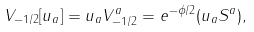<formula> <loc_0><loc_0><loc_500><loc_500>V _ { - 1 / 2 } [ u _ { a } ] = u _ { a } V _ { - 1 / 2 } ^ { a } = e ^ { - \phi / 2 } ( u _ { a } S ^ { a } ) ,</formula> 